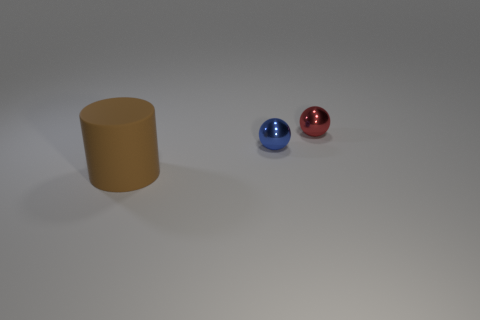Are there any other things that have the same size as the blue metallic object?
Provide a succinct answer. Yes. Does the tiny red thing have the same shape as the tiny blue metal thing?
Your response must be concise. Yes. What number of tiny objects are either yellow matte things or red objects?
Provide a short and direct response. 1. Are there any large brown matte cylinders on the right side of the tiny blue ball?
Make the answer very short. No. Are there an equal number of large things on the left side of the tiny red shiny thing and large metallic balls?
Provide a succinct answer. No. There is a red metal object that is the same shape as the small blue metallic thing; what size is it?
Keep it short and to the point. Small. Does the tiny red thing have the same shape as the small object to the left of the red sphere?
Provide a short and direct response. Yes. There is a ball left of the ball behind the blue sphere; how big is it?
Make the answer very short. Small. Are there an equal number of brown things that are behind the tiny blue shiny ball and big cylinders on the right side of the large matte cylinder?
Provide a succinct answer. Yes. What color is the other metal thing that is the same shape as the small red metallic object?
Provide a succinct answer. Blue. 